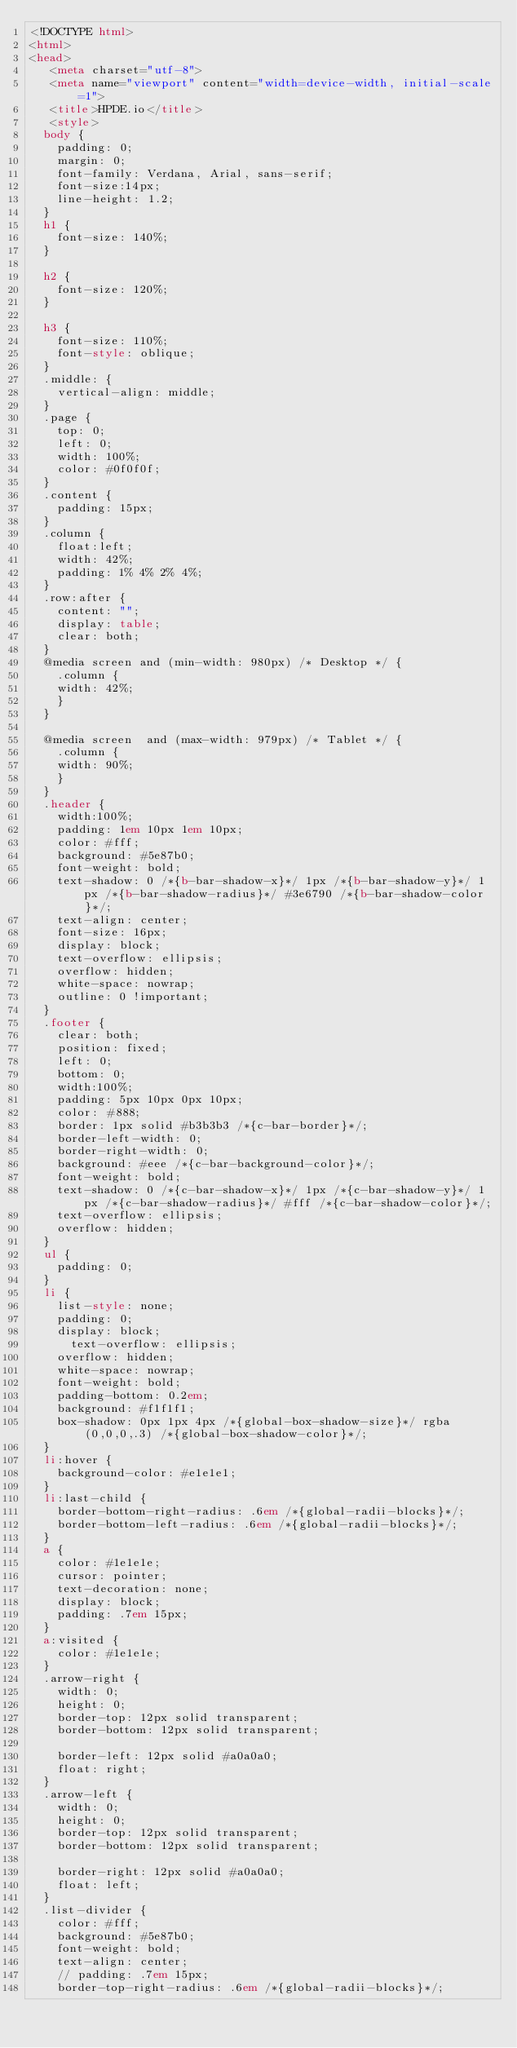Convert code to text. <code><loc_0><loc_0><loc_500><loc_500><_HTML_><!DOCTYPE html>
<html>
<head>
   <meta charset="utf-8">
   <meta name="viewport" content="width=device-width, initial-scale=1">
   <title>HPDE.io</title>
   <style>
	body {
		padding: 0;
		margin: 0;
		font-family: Verdana, Arial, sans-serif; 
		font-size:14px; 
		line-height: 1.2;
	}
	h1 {
		font-size: 140%;
	}

	h2 {
		font-size: 120%;
	}

	h3 {
		font-size: 110%;
		font-style: oblique;
	}
	.middle: {
		vertical-align: middle;
	}
	.page {
		top: 0;
		left: 0;
		width: 100%;
		color: #0f0f0f;
	}
	.content {
		padding: 15px;
	}
	.column {
		float:left;
		width: 42%;
		padding: 1% 4% 2% 4%;
	}
	.row:after {
		content: "";
		display: table;
		clear: both;
	}	
	@media screen and (min-width: 980px) /* Desktop */ {
	  .column {
		width: 42%;
	  }
	}

	@media screen  and (max-width: 979px) /* Tablet */ {
	  .column {
		width: 90%;
	  }
	}
	.header {
		width:100%;
		padding: 1em 10px 1em 10px;
		color: #fff;
		background: #5e87b0;
		font-weight: bold;
		text-shadow: 0 /*{b-bar-shadow-x}*/ 1px /*{b-bar-shadow-y}*/ 1px /*{b-bar-shadow-radius}*/ #3e6790 /*{b-bar-shadow-color}*/;
		text-align: center;
		font-size: 16px;
		display: block;
		text-overflow: ellipsis;
		overflow: hidden;
		white-space: nowrap;
		outline: 0 !important;
	}
	.footer {
		clear: both;
		position: fixed;
		left: 0;
		bottom: 0;
		width:100%;
		padding: 5px 10px 0px 10px;
		color: #888;
		border: 1px solid #b3b3b3 /*{c-bar-border}*/;
		border-left-width: 0;
		border-right-width: 0;
		background: #eee /*{c-bar-background-color}*/;
		font-weight: bold;
		text-shadow: 0 /*{c-bar-shadow-x}*/ 1px /*{c-bar-shadow-y}*/ 1px /*{c-bar-shadow-radius}*/ #fff /*{c-bar-shadow-color}*/;
		text-overflow: ellipsis;
		overflow: hidden;
	}
	ul {
		padding: 0;
	}
	li {
		list-style: none;
		padding: 0;
		display: block;
	    text-overflow: ellipsis;
		overflow: hidden;
		white-space: nowrap;
		font-weight: bold;
		padding-bottom: 0.2em;
		background: #f1f1f1;
		box-shadow: 0px 1px 4px /*{global-box-shadow-size}*/ rgba(0,0,0,.3) /*{global-box-shadow-color}*/;
	}
	li:hover {
		background-color: #e1e1e1;
	}
	li:last-child {
		border-bottom-right-radius: .6em /*{global-radii-blocks}*/;
		border-bottom-left-radius: .6em /*{global-radii-blocks}*/;
	}
	a {
		color: #1e1e1e;
		cursor: pointer;
		text-decoration: none;
		display: block;
		padding: .7em 15px;
	}
	a:visited {
		color: #1e1e1e;
	}
	.arrow-right {
	  width: 0; 
	  height: 0; 
	  border-top: 12px solid transparent;
	  border-bottom: 12px solid transparent;
	  
	  border-left: 12px solid #a0a0a0;
	  float: right;
	}
	.arrow-left {
	  width: 0; 
	  height: 0; 
	  border-top: 12px solid transparent;
	  border-bottom: 12px solid transparent;
	  
	  border-right: 12px solid #a0a0a0;
	  float: left;
	}
	.list-divider {
		color: #fff;
		background: #5e87b0;
		font-weight: bold;
		text-align: center;
		// padding: .7em 15px;
		border-top-right-radius: .6em /*{global-radii-blocks}*/;</code> 